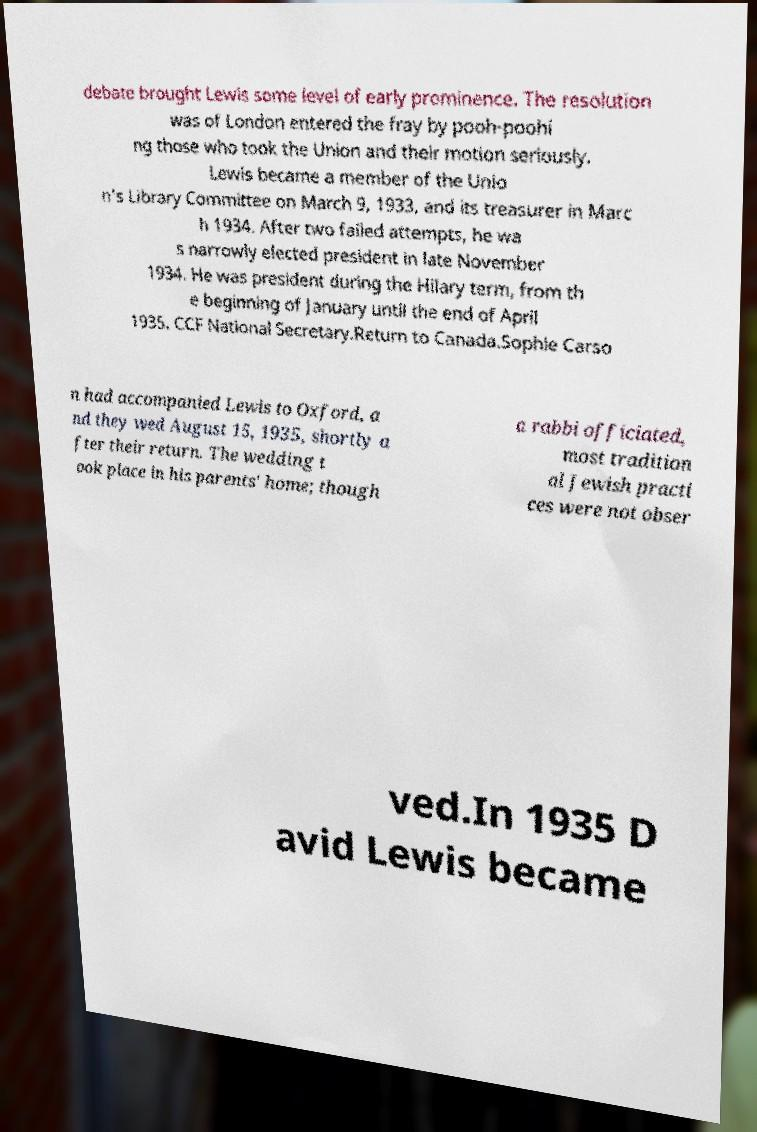Can you read and provide the text displayed in the image?This photo seems to have some interesting text. Can you extract and type it out for me? debate brought Lewis some level of early prominence. The resolution was of London entered the fray by pooh-poohi ng those who took the Union and their motion seriously. Lewis became a member of the Unio n's Library Committee on March 9, 1933, and its treasurer in Marc h 1934. After two failed attempts, he wa s narrowly elected president in late November 1934. He was president during the Hilary term, from th e beginning of January until the end of April 1935. CCF National Secretary.Return to Canada.Sophie Carso n had accompanied Lewis to Oxford, a nd they wed August 15, 1935, shortly a fter their return. The wedding t ook place in his parents' home; though a rabbi officiated, most tradition al Jewish practi ces were not obser ved.In 1935 D avid Lewis became 